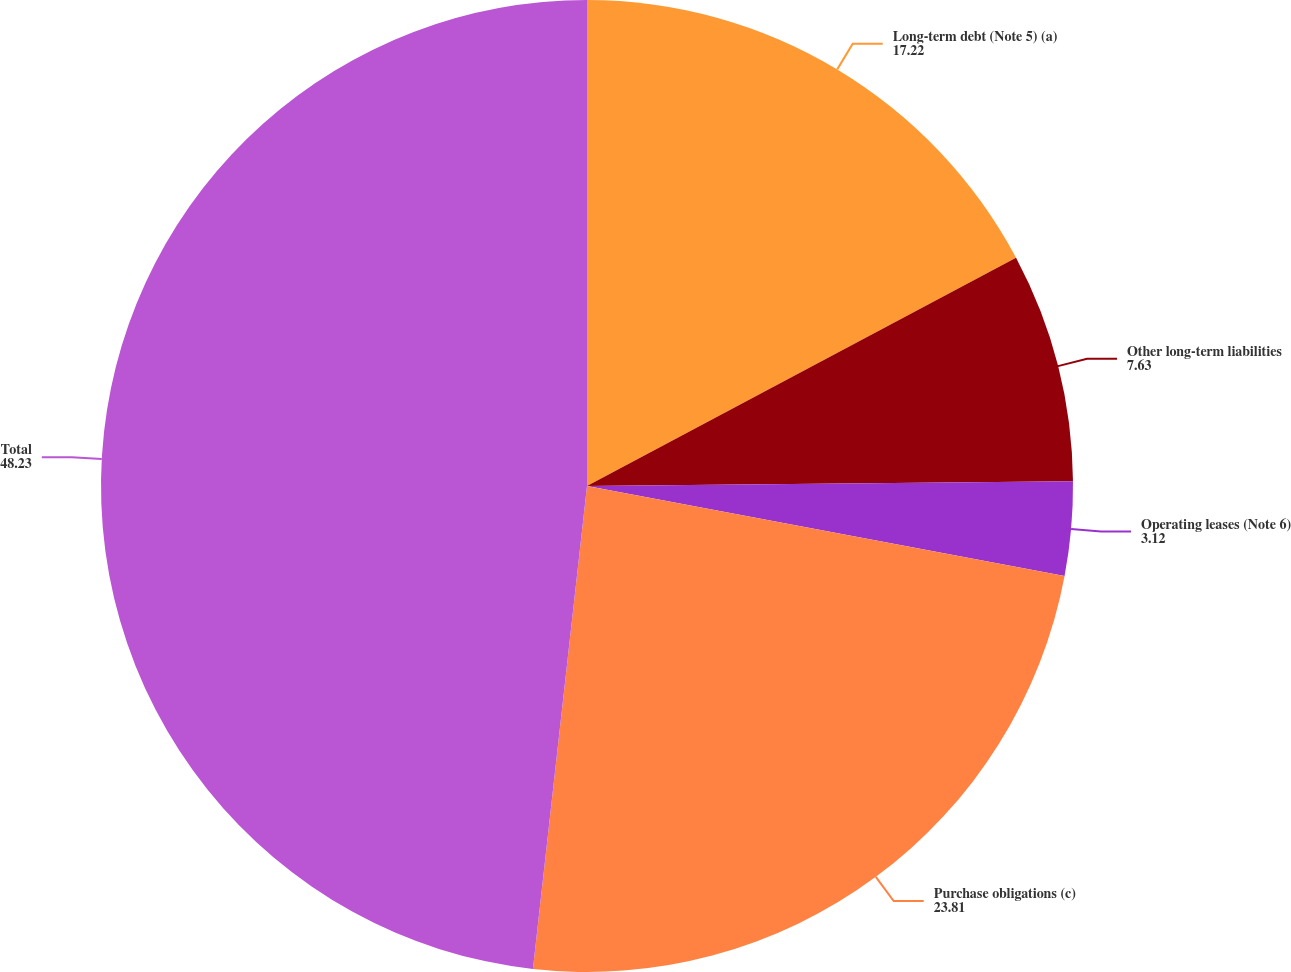Convert chart. <chart><loc_0><loc_0><loc_500><loc_500><pie_chart><fcel>Long-term debt (Note 5) (a)<fcel>Other long-term liabilities<fcel>Operating leases (Note 6)<fcel>Purchase obligations (c)<fcel>Total<nl><fcel>17.22%<fcel>7.63%<fcel>3.12%<fcel>23.81%<fcel>48.23%<nl></chart> 